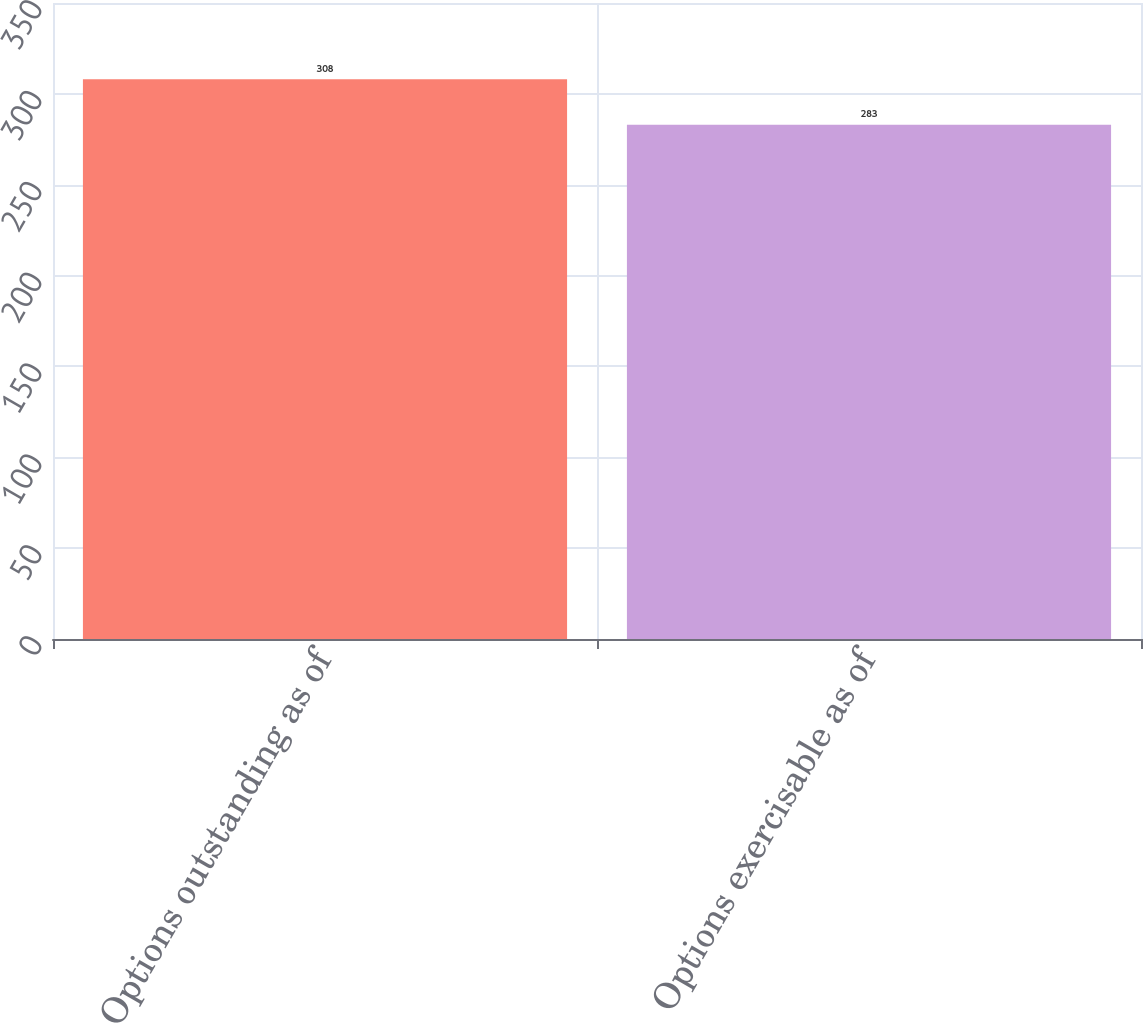<chart> <loc_0><loc_0><loc_500><loc_500><bar_chart><fcel>Options outstanding as of<fcel>Options exercisable as of<nl><fcel>308<fcel>283<nl></chart> 